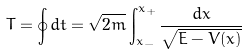Convert formula to latex. <formula><loc_0><loc_0><loc_500><loc_500>T = \oint d t = \sqrt { 2 m } \int _ { x _ { - } } ^ { x _ { + } } \frac { d x } { \sqrt { E - V ( x ) } }</formula> 